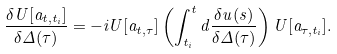<formula> <loc_0><loc_0><loc_500><loc_500>\frac { \delta { U } [ a _ { t , t _ { i } } ] } { \delta \Delta ( \tau ) } = - i { U } [ a _ { t , \tau } ] \left ( \int _ { t _ { i } } ^ { t } d \frac { \delta { u } ( s ) } { \delta \Delta ( \tau ) } \right ) { U } [ a _ { \tau , t _ { i } } ] .</formula> 